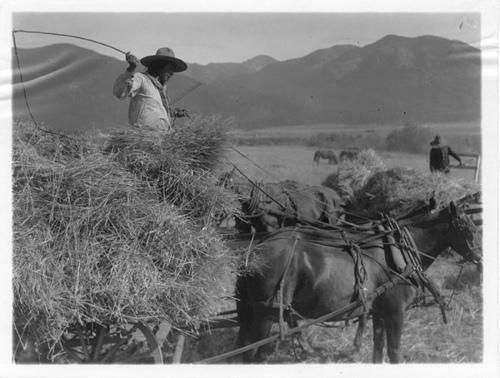How many horses can you see?
Give a very brief answer. 3. 